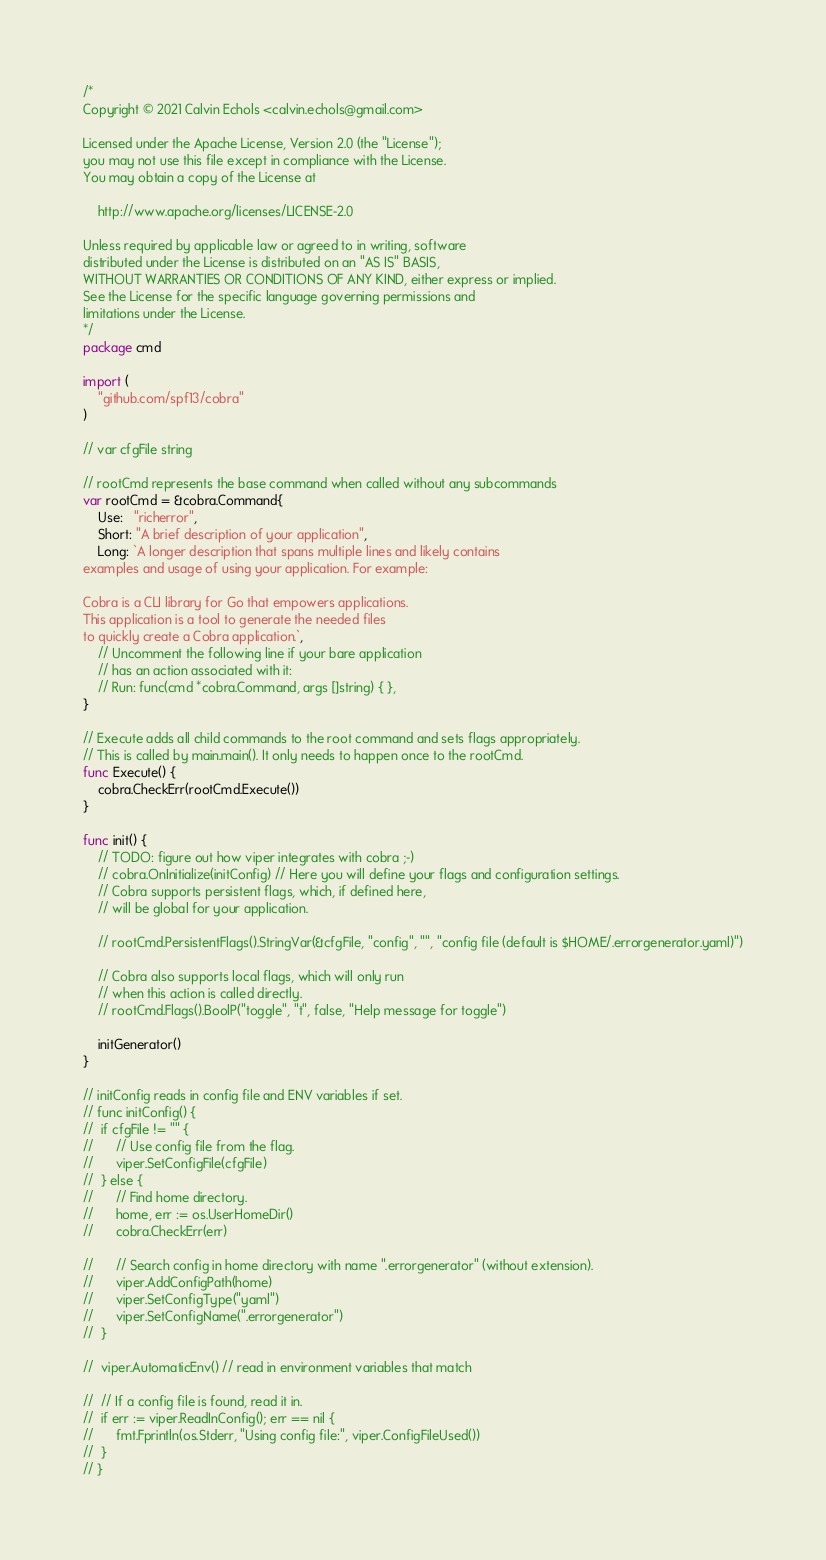Convert code to text. <code><loc_0><loc_0><loc_500><loc_500><_Go_>/*
Copyright © 2021 Calvin Echols <calvin.echols@gmail.com>

Licensed under the Apache License, Version 2.0 (the "License");
you may not use this file except in compliance with the License.
You may obtain a copy of the License at

    http://www.apache.org/licenses/LICENSE-2.0

Unless required by applicable law or agreed to in writing, software
distributed under the License is distributed on an "AS IS" BASIS,
WITHOUT WARRANTIES OR CONDITIONS OF ANY KIND, either express or implied.
See the License for the specific language governing permissions and
limitations under the License.
*/
package cmd

import (
	"github.com/spf13/cobra"
)

// var cfgFile string

// rootCmd represents the base command when called without any subcommands
var rootCmd = &cobra.Command{
	Use:   "richerror",
	Short: "A brief description of your application",
	Long: `A longer description that spans multiple lines and likely contains
examples and usage of using your application. For example:

Cobra is a CLI library for Go that empowers applications.
This application is a tool to generate the needed files
to quickly create a Cobra application.`,
	// Uncomment the following line if your bare application
	// has an action associated with it:
	// Run: func(cmd *cobra.Command, args []string) { },
}

// Execute adds all child commands to the root command and sets flags appropriately.
// This is called by main.main(). It only needs to happen once to the rootCmd.
func Execute() {
	cobra.CheckErr(rootCmd.Execute())
}

func init() {
	// TODO: figure out how viper integrates with cobra ;-)
	// cobra.OnInitialize(initConfig) // Here you will define your flags and configuration settings.
	// Cobra supports persistent flags, which, if defined here,
	// will be global for your application.

	// rootCmd.PersistentFlags().StringVar(&cfgFile, "config", "", "config file (default is $HOME/.errorgenerator.yaml)")

	// Cobra also supports local flags, which will only run
	// when this action is called directly.
	// rootCmd.Flags().BoolP("toggle", "t", false, "Help message for toggle")

	initGenerator()
}

// initConfig reads in config file and ENV variables if set.
// func initConfig() {
// 	if cfgFile != "" {
// 		// Use config file from the flag.
// 		viper.SetConfigFile(cfgFile)
// 	} else {
// 		// Find home directory.
// 		home, err := os.UserHomeDir()
// 		cobra.CheckErr(err)

// 		// Search config in home directory with name ".errorgenerator" (without extension).
// 		viper.AddConfigPath(home)
// 		viper.SetConfigType("yaml")
// 		viper.SetConfigName(".errorgenerator")
// 	}

// 	viper.AutomaticEnv() // read in environment variables that match

// 	// If a config file is found, read it in.
// 	if err := viper.ReadInConfig(); err == nil {
// 		fmt.Fprintln(os.Stderr, "Using config file:", viper.ConfigFileUsed())
// 	}
// }
</code> 